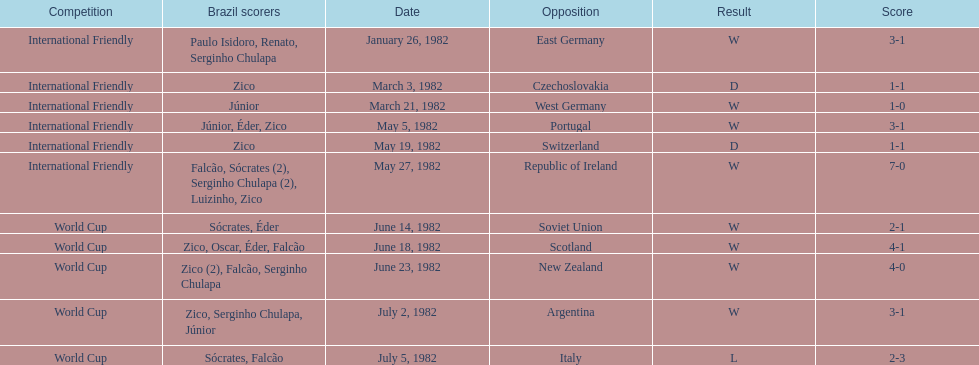Who won on january 26, 1982 and may 27, 1982? Brazil. 